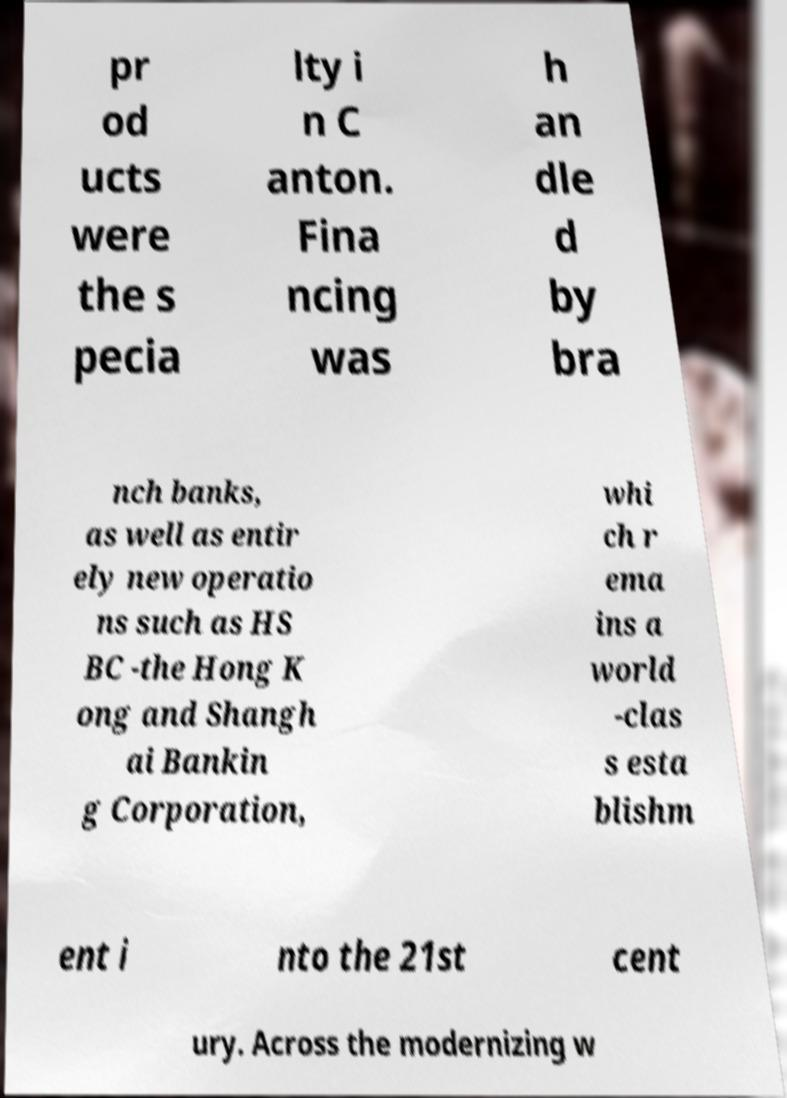Could you extract and type out the text from this image? pr od ucts were the s pecia lty i n C anton. Fina ncing was h an dle d by bra nch banks, as well as entir ely new operatio ns such as HS BC -the Hong K ong and Shangh ai Bankin g Corporation, whi ch r ema ins a world -clas s esta blishm ent i nto the 21st cent ury. Across the modernizing w 